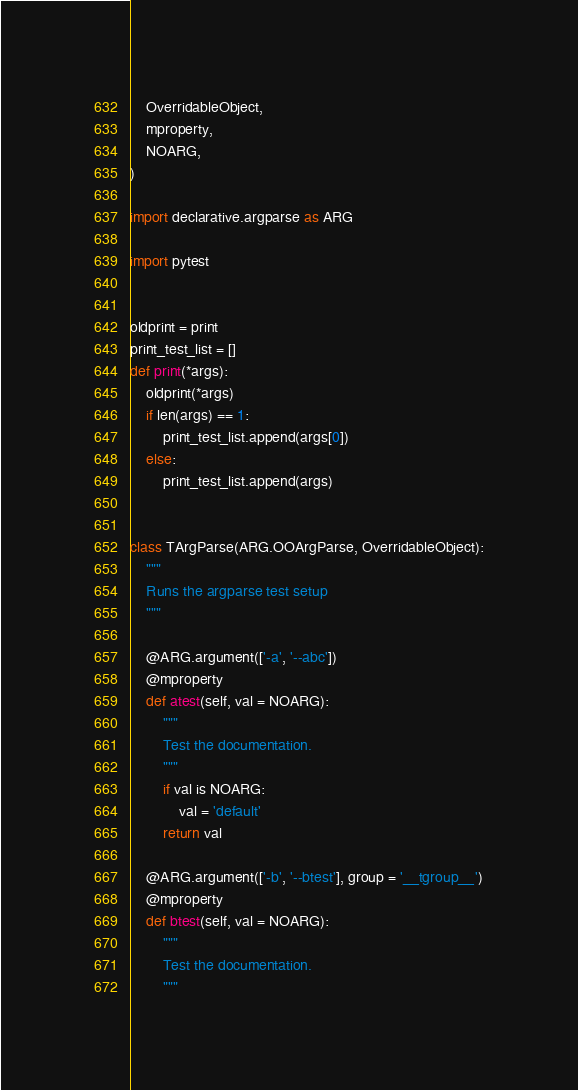Convert code to text. <code><loc_0><loc_0><loc_500><loc_500><_Python_>    OverridableObject,
    mproperty,
    NOARG,
)

import declarative.argparse as ARG

import pytest


oldprint = print
print_test_list = []
def print(*args):
    oldprint(*args)
    if len(args) == 1:
        print_test_list.append(args[0])
    else:
        print_test_list.append(args)


class TArgParse(ARG.OOArgParse, OverridableObject):
    """
    Runs the argparse test setup
    """

    @ARG.argument(['-a', '--abc'])
    @mproperty
    def atest(self, val = NOARG):
        """
        Test the documentation.
        """
        if val is NOARG:
            val = 'default'
        return val

    @ARG.argument(['-b', '--btest'], group = '__tgroup__')
    @mproperty
    def btest(self, val = NOARG):
        """
        Test the documentation.
        """</code> 